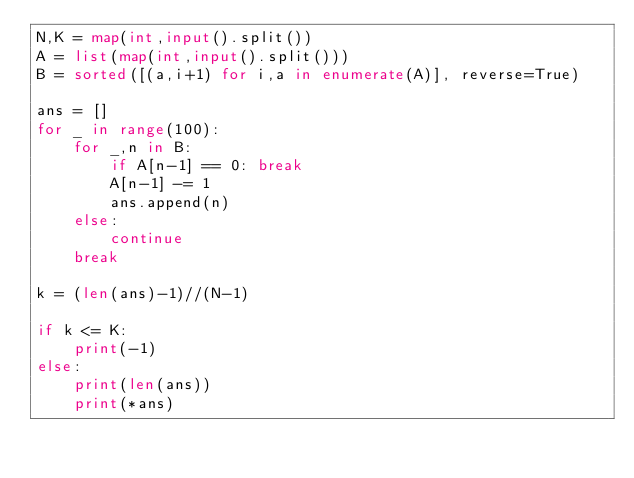Convert code to text. <code><loc_0><loc_0><loc_500><loc_500><_Python_>N,K = map(int,input().split())
A = list(map(int,input().split()))
B = sorted([(a,i+1) for i,a in enumerate(A)], reverse=True)

ans = []
for _ in range(100):
    for _,n in B:
        if A[n-1] == 0: break
        A[n-1] -= 1
        ans.append(n)
    else:
        continue
    break

k = (len(ans)-1)//(N-1)

if k <= K:
    print(-1)
else:
    print(len(ans))
    print(*ans)</code> 